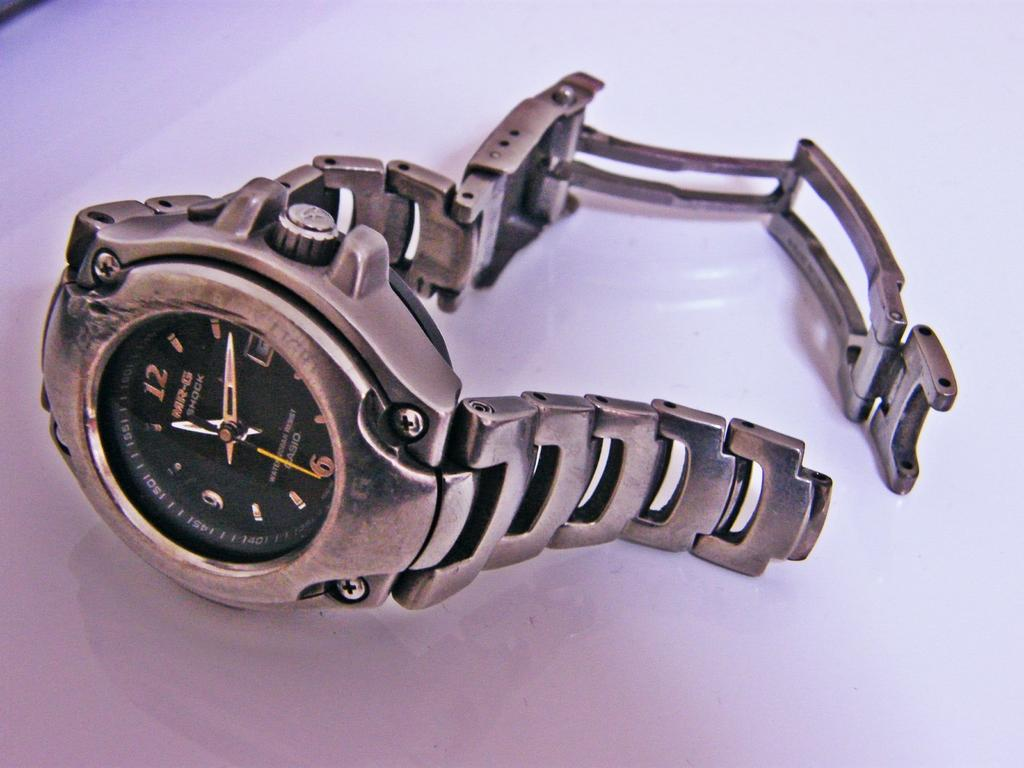<image>
Offer a succinct explanation of the picture presented. A silver and black MR-G Shock Casio Watch. 